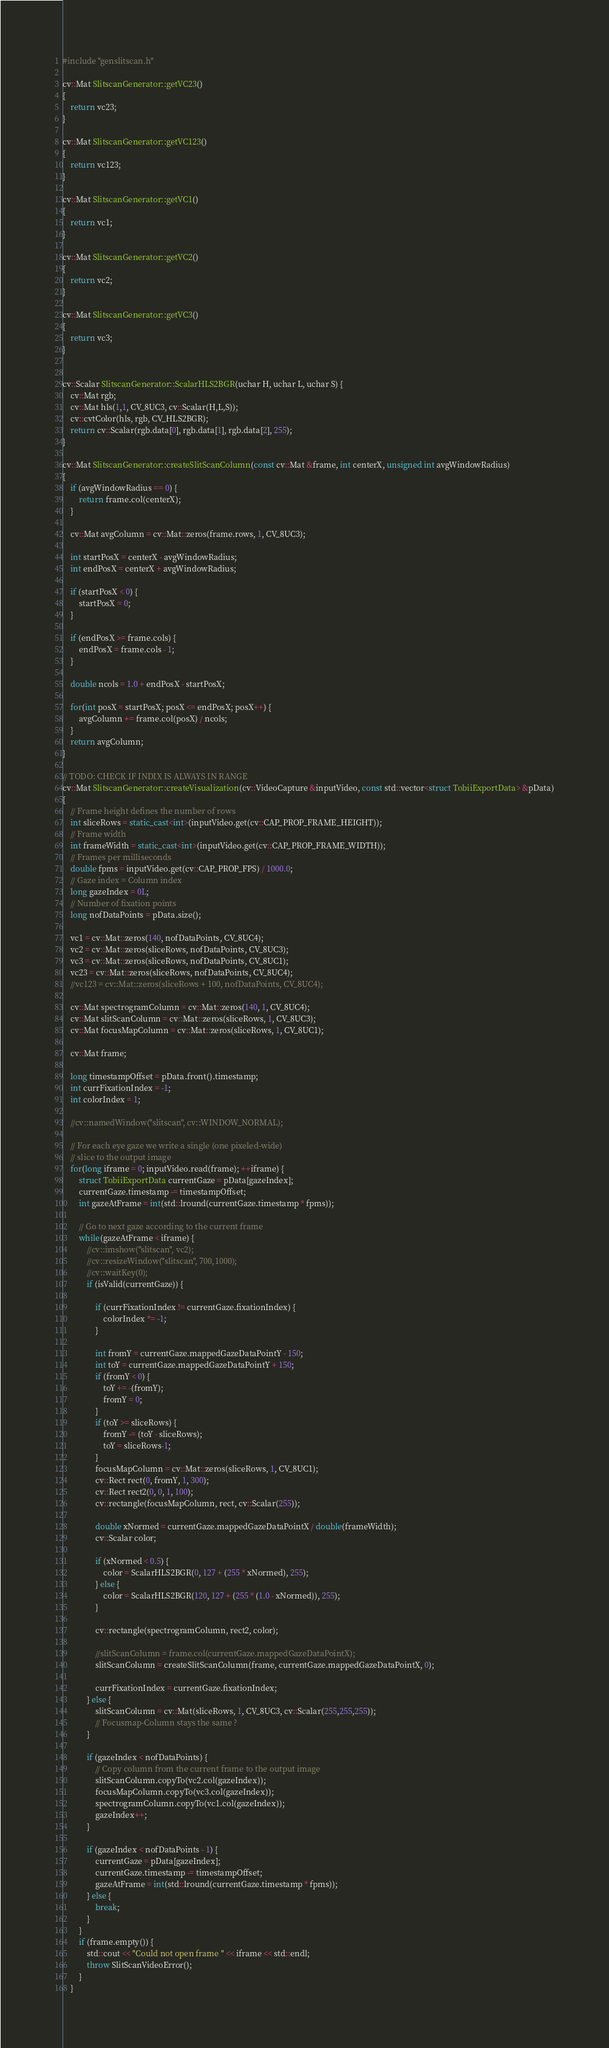Convert code to text. <code><loc_0><loc_0><loc_500><loc_500><_C++_>#include "genslitscan.h"

cv::Mat SlitscanGenerator::getVC23()
{
    return vc23;
}

cv::Mat SlitscanGenerator::getVC123()
{
    return vc123;
}

cv::Mat SlitscanGenerator::getVC1()
{
    return vc1;
}

cv::Mat SlitscanGenerator::getVC2()
{
    return vc2;
}

cv::Mat SlitscanGenerator::getVC3()
{
    return vc3;
}


cv::Scalar SlitscanGenerator::ScalarHLS2BGR(uchar H, uchar L, uchar S) {
    cv::Mat rgb;
    cv::Mat hls(1,1, CV_8UC3, cv::Scalar(H,L,S));
    cv::cvtColor(hls, rgb, CV_HLS2BGR);
    return cv::Scalar(rgb.data[0], rgb.data[1], rgb.data[2], 255);
}

cv::Mat SlitscanGenerator::createSlitScanColumn(const cv::Mat &frame, int centerX, unsigned int avgWindowRadius)
{
    if (avgWindowRadius == 0) {
        return frame.col(centerX);
    }

    cv::Mat avgColumn = cv::Mat::zeros(frame.rows, 1, CV_8UC3);

    int startPosX = centerX - avgWindowRadius;
    int endPosX = centerX + avgWindowRadius;

    if (startPosX < 0) {
        startPosX = 0;
    }

    if (endPosX >= frame.cols) {
        endPosX = frame.cols - 1;
    }

    double ncols = 1.0 + endPosX - startPosX;

    for(int posX = startPosX; posX <= endPosX; posX++) {
        avgColumn += frame.col(posX) / ncols;
    }
    return avgColumn;
}

// TODO: CHECK IF INDIX IS ALWAYS IN RANGE
cv::Mat SlitscanGenerator::createVisualization(cv::VideoCapture &inputVideo, const std::vector<struct TobiiExportData> &pData)
{
    // Frame height defines the number of rows
    int sliceRows = static_cast<int>(inputVideo.get(cv::CAP_PROP_FRAME_HEIGHT));
    // Frame width
    int frameWidth = static_cast<int>(inputVideo.get(cv::CAP_PROP_FRAME_WIDTH));
    // Frames per milliseconds
    double fpms = inputVideo.get(cv::CAP_PROP_FPS) / 1000.0;
    // Gaze index = Column index
    long gazeIndex = 0L;
    // Number of fixation points
    long nofDataPoints = pData.size();

    vc1 = cv::Mat::zeros(140, nofDataPoints, CV_8UC4);
    vc2 = cv::Mat::zeros(sliceRows, nofDataPoints, CV_8UC3);
    vc3 = cv::Mat::zeros(sliceRows, nofDataPoints, CV_8UC1);
    vc23 = cv::Mat::zeros(sliceRows, nofDataPoints, CV_8UC4);
    //vc123 = cv::Mat::zeros(sliceRows + 100, nofDataPoints, CV_8UC4);

    cv::Mat spectrogramColumn = cv::Mat::zeros(140, 1, CV_8UC4);
    cv::Mat slitScanColumn = cv::Mat::zeros(sliceRows, 1, CV_8UC3);
    cv::Mat focusMapColumn = cv::Mat::zeros(sliceRows, 1, CV_8UC1);

    cv::Mat frame;

    long timestampOffset = pData.front().timestamp;
    int currFixationIndex = -1;
    int colorIndex = 1;

    //cv::namedWindow("slitscan", cv::WINDOW_NORMAL);

    // For each eye gaze we write a single (one pixeled-wide)
    // slice to the output image
    for(long iframe = 0; inputVideo.read(frame); ++iframe) {
        struct TobiiExportData currentGaze = pData[gazeIndex];
        currentGaze.timestamp -= timestampOffset;
        int gazeAtFrame = int(std::lround(currentGaze.timestamp * fpms));

        // Go to next gaze according to the current frame
        while(gazeAtFrame < iframe) {
            //cv::imshow("slitscan", vc2);
            //cv::resizeWindow("slitscan", 700,1000);
            //cv::waitKey(0);
            if (isValid(currentGaze)) {

                if (currFixationIndex != currentGaze.fixationIndex) {
                    colorIndex *= -1;
                }

                int fromY = currentGaze.mappedGazeDataPointY - 150;
                int toY = currentGaze.mappedGazeDataPointY + 150;
                if (fromY < 0) {
                    toY += -(fromY);
                    fromY = 0;
                }
                if (toY >= sliceRows) {
                    fromY -= (toY - sliceRows);
                    toY = sliceRows-1;
                }
                focusMapColumn = cv::Mat::zeros(sliceRows, 1, CV_8UC1);
                cv::Rect rect(0, fromY, 1, 300);
                cv::Rect rect2(0, 0, 1, 100);
                cv::rectangle(focusMapColumn, rect, cv::Scalar(255));

                double xNormed = currentGaze.mappedGazeDataPointX / double(frameWidth);
                cv::Scalar color;

                if (xNormed < 0.5) {
                    color = ScalarHLS2BGR(0, 127 + (255 * xNormed), 255);
                } else {
                    color = ScalarHLS2BGR(120, 127 + (255 * (1.0 - xNormed)), 255);
                }

                cv::rectangle(spectrogramColumn, rect2, color);

                //slitScanColumn = frame.col(currentGaze.mappedGazeDataPointX);
                slitScanColumn = createSlitScanColumn(frame, currentGaze.mappedGazeDataPointX, 0);

                currFixationIndex = currentGaze.fixationIndex;
            } else {
                slitScanColumn = cv::Mat(sliceRows, 1, CV_8UC3, cv::Scalar(255,255,255));
                // Focusmap-Column stays the same ?
            }

            if (gazeIndex < nofDataPoints) {
                // Copy column from the current frame to the output image
                slitScanColumn.copyTo(vc2.col(gazeIndex));
                focusMapColumn.copyTo(vc3.col(gazeIndex));
                spectrogramColumn.copyTo(vc1.col(gazeIndex));
                gazeIndex++;
            }

            if (gazeIndex < nofDataPoints - 1) {
                currentGaze = pData[gazeIndex];
                currentGaze.timestamp -= timestampOffset;
                gazeAtFrame = int(std::lround(currentGaze.timestamp * fpms));
            } else {
                break;
            }
        }
        if (frame.empty()) {
            std::cout << "Could not open frame " << iframe << std::endl;
            throw SlitScanVideoError();
        }
    }
</code> 